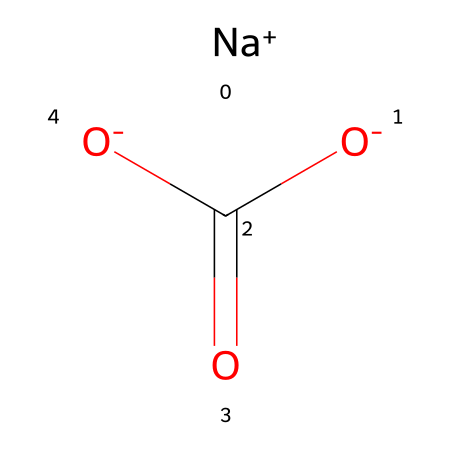What is the common name of the compound represented by this SMILES? The SMILES representation indicates sodium bicarbonate, which is a common antacid used for digestive issues. The inclusion of sodium and the bicarbonate group (HCO3) in the structure signifies this name.
Answer: sodium bicarbonate How many oxygen atoms are present in this molecule? In the SMILES, the notation indicates three oxygen atoms; one as part of the carbonate ion (C(=O)[O-]) and two from the bidentate part of the structure. Count them to verify.
Answer: three Is the compound a strong or weak base? Sodium bicarbonate is a weak base as it only partially dissociates in solution, making it effective for increasing pH without causing excessive alkalinity.
Answer: weak What charge does the sodium ion carry? The notation [Na+] indicates that the sodium ion has a positive charge of +1. This is a common feature of alkali metals in their ionic form.
Answer: +1 How many hydrogen atoms are in sodium bicarbonate? The structure includes one hydrogen atom associated with the bicarbonate part of the compound, which is represented in the molecular structure but is not explicitly shown here. A bicarbonate ion usually incorporates one hydrogen.
Answer: one What type of reaction does sodium bicarbonate undergo when it neutralizes stomach acid? Sodium bicarbonate undergoes a neutralization reaction with hydrochloric acid (HCl) to form sodium chloride, water, and carbon dioxide, demonstrating its role as an antacid. This chemical behavior defines its use in digestive contexts.
Answer: neutralization What is the pH level of the solution when sodium bicarbonate dissolves in water? The addition of sodium bicarbonate to water typically results in a mildly basic pH level around 8-9, illustrating its buffering capacity.
Answer: 8-9 